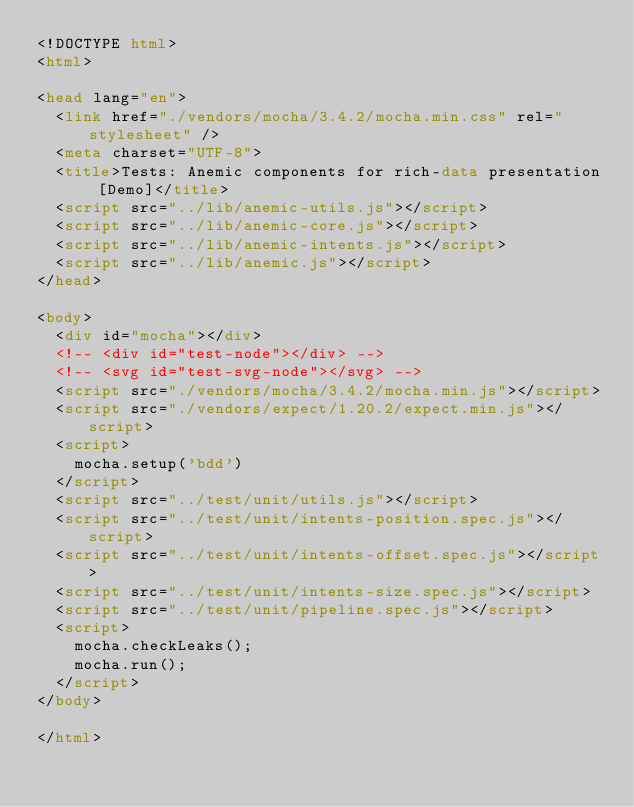<code> <loc_0><loc_0><loc_500><loc_500><_HTML_><!DOCTYPE html>
<html>

<head lang="en">
  <link href="./vendors/mocha/3.4.2/mocha.min.css" rel="stylesheet" />
  <meta charset="UTF-8">
  <title>Tests: Anemic components for rich-data presentation [Demo]</title>
  <script src="../lib/anemic-utils.js"></script>
  <script src="../lib/anemic-core.js"></script>
  <script src="../lib/anemic-intents.js"></script>
  <script src="../lib/anemic.js"></script>
</head>

<body>
  <div id="mocha"></div>
  <!-- <div id="test-node"></div> -->
  <!-- <svg id="test-svg-node"></svg> -->
  <script src="./vendors/mocha/3.4.2/mocha.min.js"></script>
  <script src="./vendors/expect/1.20.2/expect.min.js"></script>
  <script>
    mocha.setup('bdd')
  </script>
  <script src="../test/unit/utils.js"></script>
  <script src="../test/unit/intents-position.spec.js"></script>
  <script src="../test/unit/intents-offset.spec.js"></script>
  <script src="../test/unit/intents-size.spec.js"></script>
  <script src="../test/unit/pipeline.spec.js"></script>
  <script>
    mocha.checkLeaks();
    mocha.run();
  </script>
</body>

</html>
</code> 